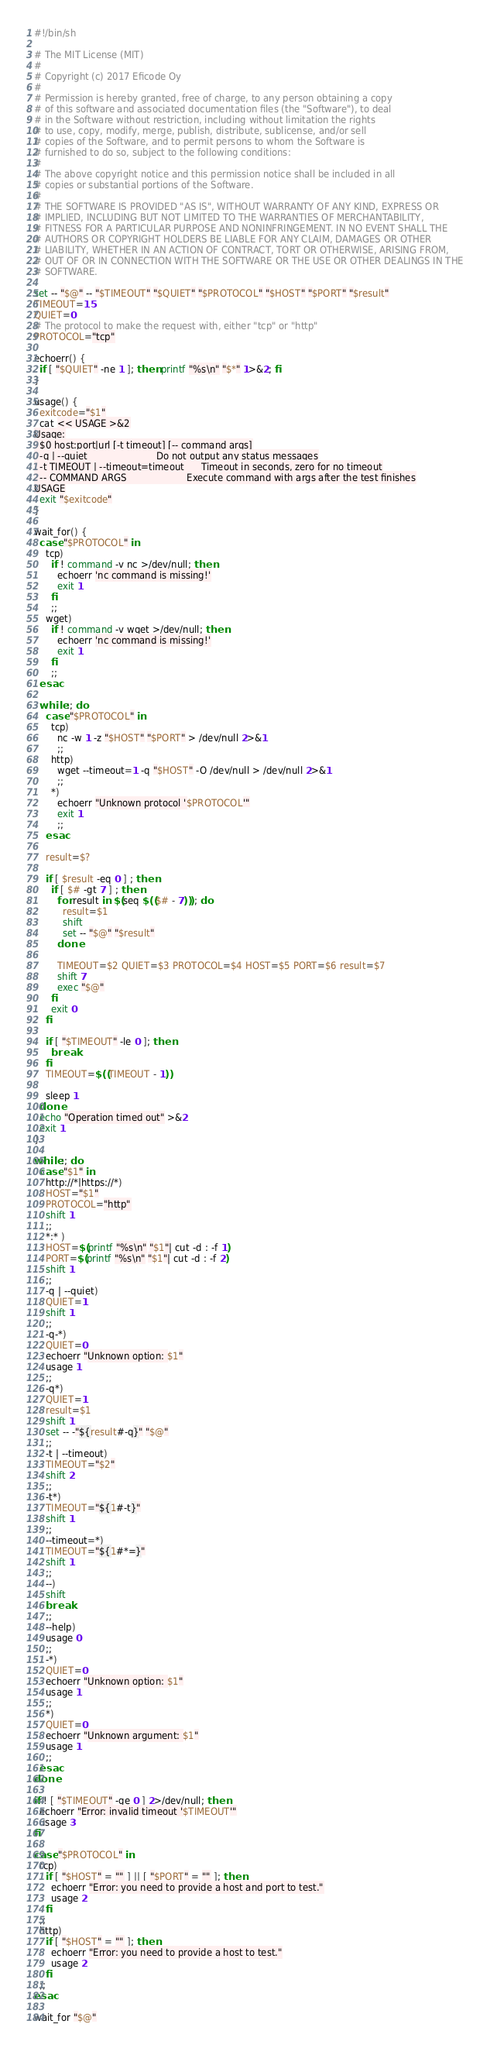<code> <loc_0><loc_0><loc_500><loc_500><_Bash_>#!/bin/sh

# The MIT License (MIT)
#
# Copyright (c) 2017 Eficode Oy
#
# Permission is hereby granted, free of charge, to any person obtaining a copy
# of this software and associated documentation files (the "Software"), to deal
# in the Software without restriction, including without limitation the rights
# to use, copy, modify, merge, publish, distribute, sublicense, and/or sell
# copies of the Software, and to permit persons to whom the Software is
# furnished to do so, subject to the following conditions:
#
# The above copyright notice and this permission notice shall be included in all
# copies or substantial portions of the Software.
#
# THE SOFTWARE IS PROVIDED "AS IS", WITHOUT WARRANTY OF ANY KIND, EXPRESS OR
# IMPLIED, INCLUDING BUT NOT LIMITED TO THE WARRANTIES OF MERCHANTABILITY,
# FITNESS FOR A PARTICULAR PURPOSE AND NONINFRINGEMENT. IN NO EVENT SHALL THE
# AUTHORS OR COPYRIGHT HOLDERS BE LIABLE FOR ANY CLAIM, DAMAGES OR OTHER
# LIABILITY, WHETHER IN AN ACTION OF CONTRACT, TORT OR OTHERWISE, ARISING FROM,
# OUT OF OR IN CONNECTION WITH THE SOFTWARE OR THE USE OR OTHER DEALINGS IN THE
# SOFTWARE.

set -- "$@" -- "$TIMEOUT" "$QUIET" "$PROTOCOL" "$HOST" "$PORT" "$result"
TIMEOUT=15
QUIET=0
# The protocol to make the request with, either "tcp" or "http"
PROTOCOL="tcp"

echoerr() {
  if [ "$QUIET" -ne 1 ]; then printf "%s\n" "$*" 1>&2; fi
}

usage() {
  exitcode="$1"
  cat << USAGE >&2
Usage:
  $0 host:port|url [-t timeout] [-- command args]
  -q | --quiet                        Do not output any status messages
  -t TIMEOUT | --timeout=timeout      Timeout in seconds, zero for no timeout
  -- COMMAND ARGS                     Execute command with args after the test finishes
USAGE
  exit "$exitcode"
}

wait_for() {
  case "$PROTOCOL" in
    tcp)
      if ! command -v nc >/dev/null; then
        echoerr 'nc command is missing!'
        exit 1
      fi
      ;;
    wget)
      if ! command -v wget >/dev/null; then
        echoerr 'nc command is missing!'
        exit 1
      fi
      ;;
  esac

  while :; do
    case "$PROTOCOL" in
      tcp) 
        nc -w 1 -z "$HOST" "$PORT" > /dev/null 2>&1
        ;;
      http)
        wget --timeout=1 -q "$HOST" -O /dev/null > /dev/null 2>&1 
        ;;
      *)
        echoerr "Unknown protocol '$PROTOCOL'"
        exit 1
        ;;
    esac

    result=$?
        
    if [ $result -eq 0 ] ; then
      if [ $# -gt 7 ] ; then
        for result in $(seq $(($# - 7))); do
          result=$1
          shift
          set -- "$@" "$result"
        done

        TIMEOUT=$2 QUIET=$3 PROTOCOL=$4 HOST=$5 PORT=$6 result=$7
        shift 7
        exec "$@"
      fi
      exit 0
    fi

    if [ "$TIMEOUT" -le 0 ]; then
      break
    fi
    TIMEOUT=$((TIMEOUT - 1))

    sleep 1
  done
  echo "Operation timed out" >&2
  exit 1
}

while :; do
  case "$1" in
    http://*|https://*)
    HOST="$1"
    PROTOCOL="http"
    shift 1
    ;;
    *:* )
    HOST=$(printf "%s\n" "$1"| cut -d : -f 1)
    PORT=$(printf "%s\n" "$1"| cut -d : -f 2)
    shift 1
    ;;
    -q | --quiet)
    QUIET=1
    shift 1
    ;;
    -q-*)
    QUIET=0
    echoerr "Unknown option: $1"
    usage 1
    ;;
    -q*)
    QUIET=1
    result=$1
    shift 1
    set -- -"${result#-q}" "$@"
    ;;
    -t | --timeout)
    TIMEOUT="$2"
    shift 2
    ;;
    -t*)
    TIMEOUT="${1#-t}"
    shift 1
    ;;
    --timeout=*)
    TIMEOUT="${1#*=}"
    shift 1
    ;;
    --)
    shift
    break
    ;;
    --help)
    usage 0
    ;;
    -*)
    QUIET=0
    echoerr "Unknown option: $1"
    usage 1
    ;;
    *)
    QUIET=0
    echoerr "Unknown argument: $1"
    usage 1
    ;;
  esac
done

if ! [ "$TIMEOUT" -ge 0 ] 2>/dev/null; then
  echoerr "Error: invalid timeout '$TIMEOUT'"
  usage 3
fi

case "$PROTOCOL" in
  tcp)
    if [ "$HOST" = "" ] || [ "$PORT" = "" ]; then
      echoerr "Error: you need to provide a host and port to test."
      usage 2
    fi
  ;;
  http)
    if [ "$HOST" = "" ]; then
      echoerr "Error: you need to provide a host to test."
      usage 2
    fi
  ;;
esac

wait_for "$@"</code> 